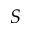<formula> <loc_0><loc_0><loc_500><loc_500>S</formula> 